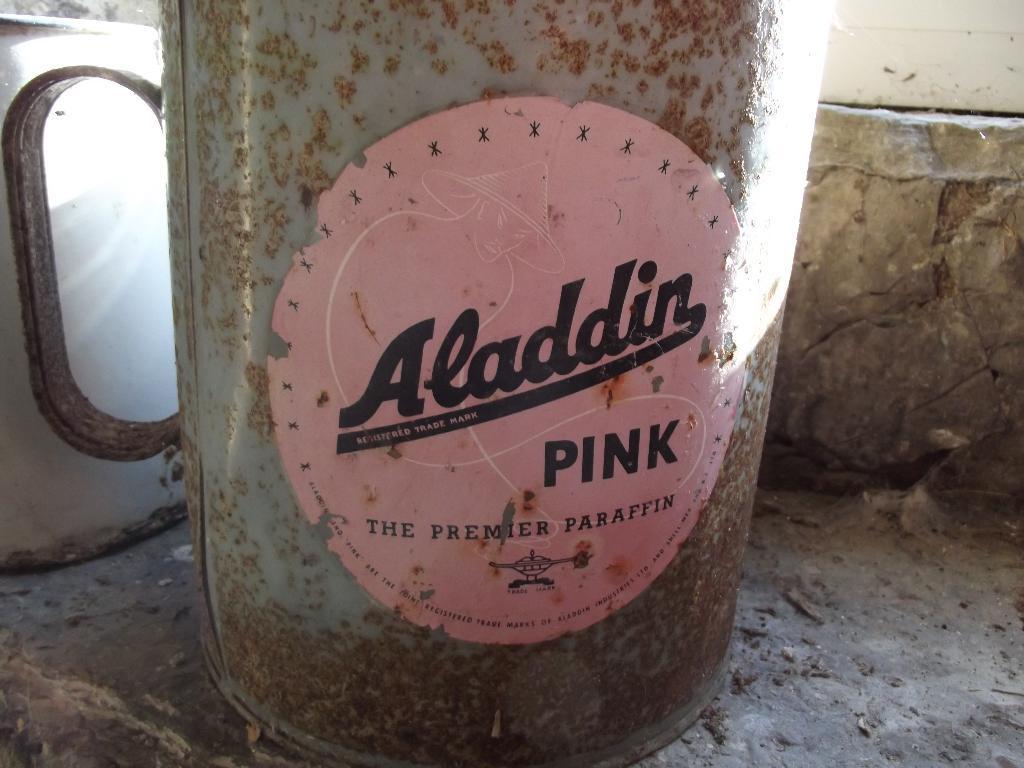How would you summarize this image in a sentence or two? In this picture there is a steel mug, on a concrete surface. On the left it is looking like a mirror. 